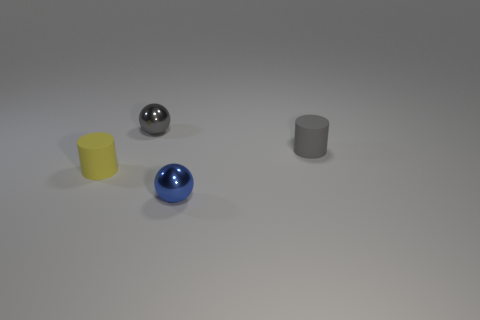Are there fewer tiny gray shiny spheres that are behind the small gray metallic object than tiny yellow matte things?
Keep it short and to the point. Yes. The gray matte thing that is the same size as the blue thing is what shape?
Provide a short and direct response. Cylinder. What number of things are either gray metallic things or metal things that are in front of the gray metal object?
Your response must be concise. 2. Is the number of gray balls on the left side of the small gray metal thing less than the number of matte things that are left of the blue thing?
Make the answer very short. Yes. What number of other objects are there of the same material as the small yellow thing?
Ensure brevity in your answer.  1. There is a ball that is on the right side of the gray metal object; is there a gray object that is on the right side of it?
Offer a terse response. Yes. There is a object that is both behind the small yellow rubber cylinder and on the left side of the blue object; what is its material?
Keep it short and to the point. Metal. There is another thing that is the same material as the yellow thing; what shape is it?
Give a very brief answer. Cylinder. Is the material of the tiny cylinder that is right of the tiny blue sphere the same as the yellow object?
Your answer should be compact. Yes. What is the tiny gray object that is on the right side of the small blue shiny object made of?
Offer a terse response. Rubber. 